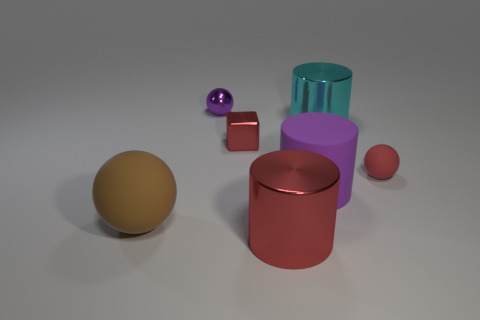There is a small metal object that is the same color as the tiny rubber thing; what is its shape? The small metal object shares the characteristic bronze color with the tiny rubber ball beside it. Upon closer examination, the shape of the metal object is not a cube but rather a rectangular prism with distinct length, width, and height dimensions, differentiating it from a cube which has all sides equal. 